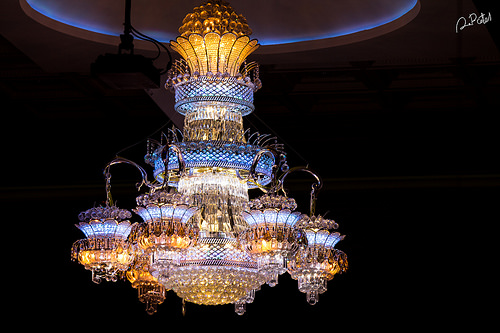<image>
Is the darkness behind the chandelier? Yes. From this viewpoint, the darkness is positioned behind the chandelier, with the chandelier partially or fully occluding the darkness. 